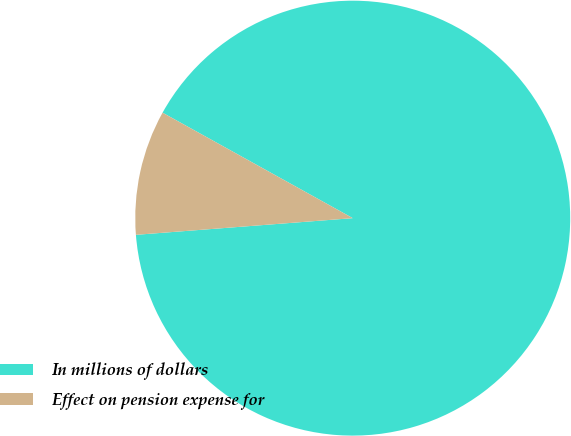Convert chart. <chart><loc_0><loc_0><loc_500><loc_500><pie_chart><fcel>In millions of dollars<fcel>Effect on pension expense for<nl><fcel>90.72%<fcel>9.28%<nl></chart> 